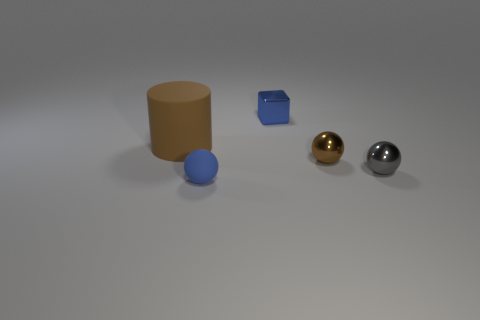Subtract all brown shiny spheres. How many spheres are left? 2 Add 2 tiny blue balls. How many objects exist? 7 Subtract all brown balls. How many balls are left? 2 Subtract all blocks. How many objects are left? 4 Add 1 large blue metallic blocks. How many large blue metallic blocks exist? 1 Subtract 0 brown blocks. How many objects are left? 5 Subtract 2 spheres. How many spheres are left? 1 Subtract all blue spheres. Subtract all brown cylinders. How many spheres are left? 2 Subtract all purple blocks. How many red cylinders are left? 0 Subtract all tiny rubber cylinders. Subtract all brown shiny balls. How many objects are left? 4 